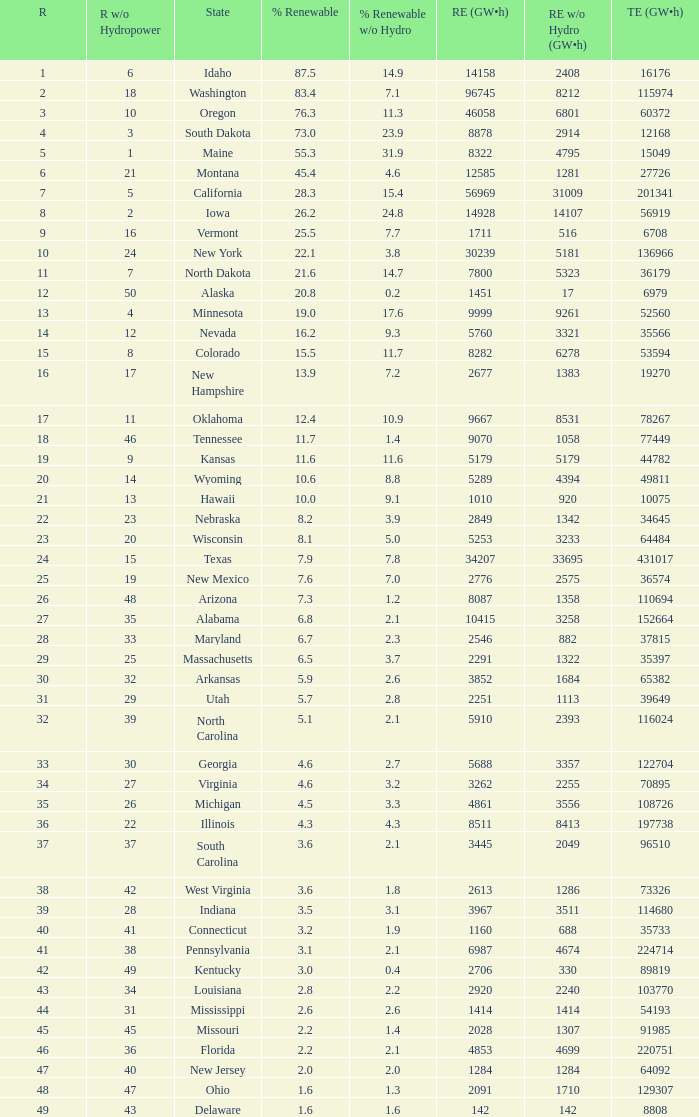When renewable electricity is 5760 (gw×h) what is the minimum amount of renewable elecrrixity without hydrogen power? 3321.0. 